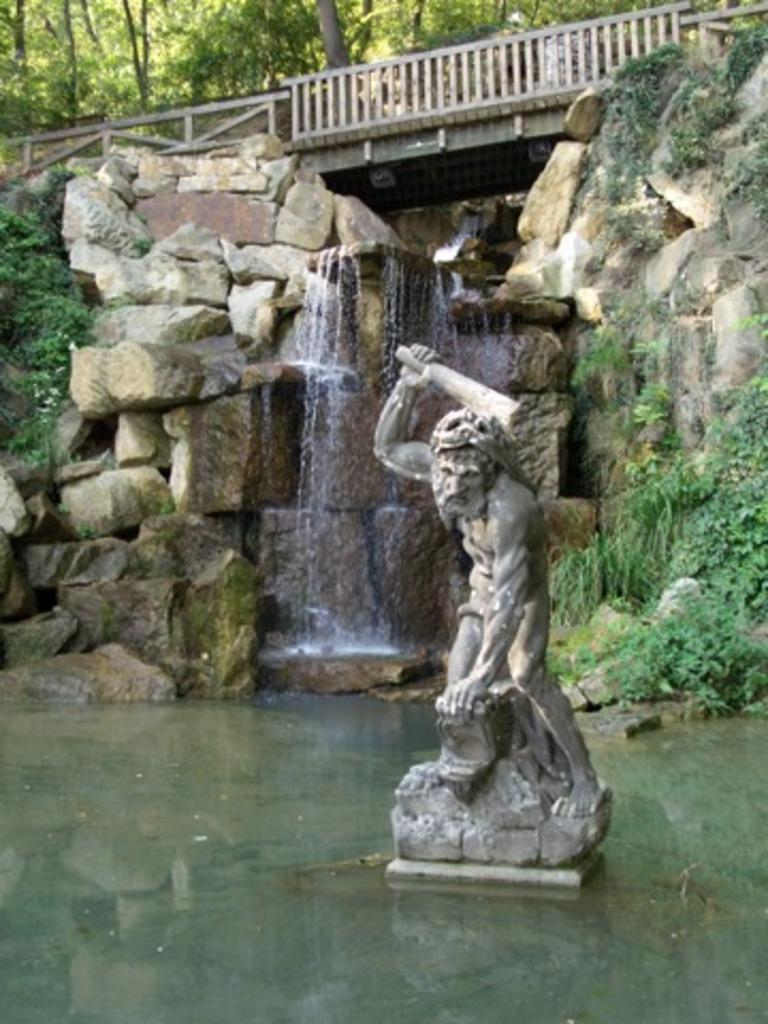What is located in the water in the foreground of the image? There is a statue in the water in the foreground. What can be seen in the background of the image? There is a waterfall, stones, greenery, and a railing in the background. What type of vegetation is visible at the top of the image? Trees are visible at the top of the image. What type of star can be seen in the image? There is no star present in the image. What is the relationship between the statue and the waterfall in the image? The provided facts do not mention any relationship between the statue and the waterfall; they are simply two separate elements in the image. 